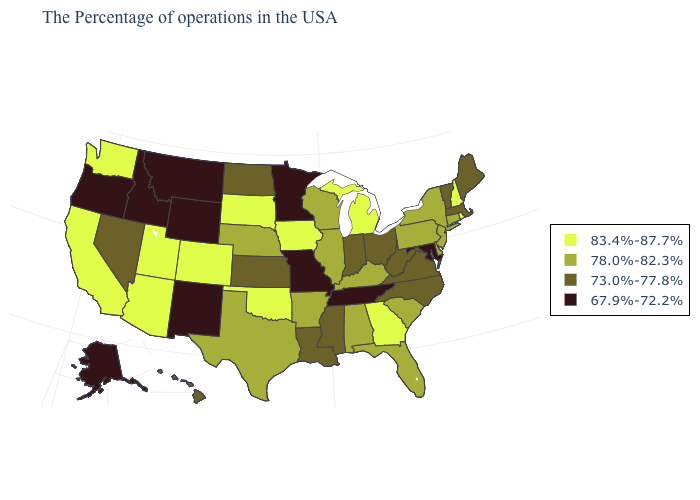What is the value of South Carolina?
Quick response, please. 78.0%-82.3%. What is the value of Nebraska?
Short answer required. 78.0%-82.3%. Does the map have missing data?
Concise answer only. No. Name the states that have a value in the range 83.4%-87.7%?
Quick response, please. Rhode Island, New Hampshire, Georgia, Michigan, Iowa, Oklahoma, South Dakota, Colorado, Utah, Arizona, California, Washington. What is the lowest value in states that border Indiana?
Short answer required. 73.0%-77.8%. Which states have the lowest value in the USA?
Concise answer only. Maryland, Tennessee, Missouri, Minnesota, Wyoming, New Mexico, Montana, Idaho, Oregon, Alaska. Does Tennessee have the lowest value in the South?
Short answer required. Yes. Which states hav the highest value in the West?
Answer briefly. Colorado, Utah, Arizona, California, Washington. What is the value of Utah?
Write a very short answer. 83.4%-87.7%. Which states have the highest value in the USA?
Keep it brief. Rhode Island, New Hampshire, Georgia, Michigan, Iowa, Oklahoma, South Dakota, Colorado, Utah, Arizona, California, Washington. Does Alabama have a lower value than New Hampshire?
Be succinct. Yes. What is the value of Wisconsin?
Give a very brief answer. 78.0%-82.3%. Among the states that border Montana , which have the highest value?
Concise answer only. South Dakota. What is the lowest value in states that border South Dakota?
Concise answer only. 67.9%-72.2%. Name the states that have a value in the range 67.9%-72.2%?
Keep it brief. Maryland, Tennessee, Missouri, Minnesota, Wyoming, New Mexico, Montana, Idaho, Oregon, Alaska. 